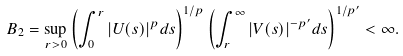<formula> <loc_0><loc_0><loc_500><loc_500>B _ { 2 } = \sup _ { r > 0 } \left ( \int _ { 0 } ^ { r } | U ( s ) | ^ { p } d s \right ) ^ { 1 / p } \left ( \int _ { r } ^ { \infty } | V ( s ) | ^ { - p ^ { \prime } } d s \right ) ^ { 1 / p ^ { \prime } } < \infty .</formula> 